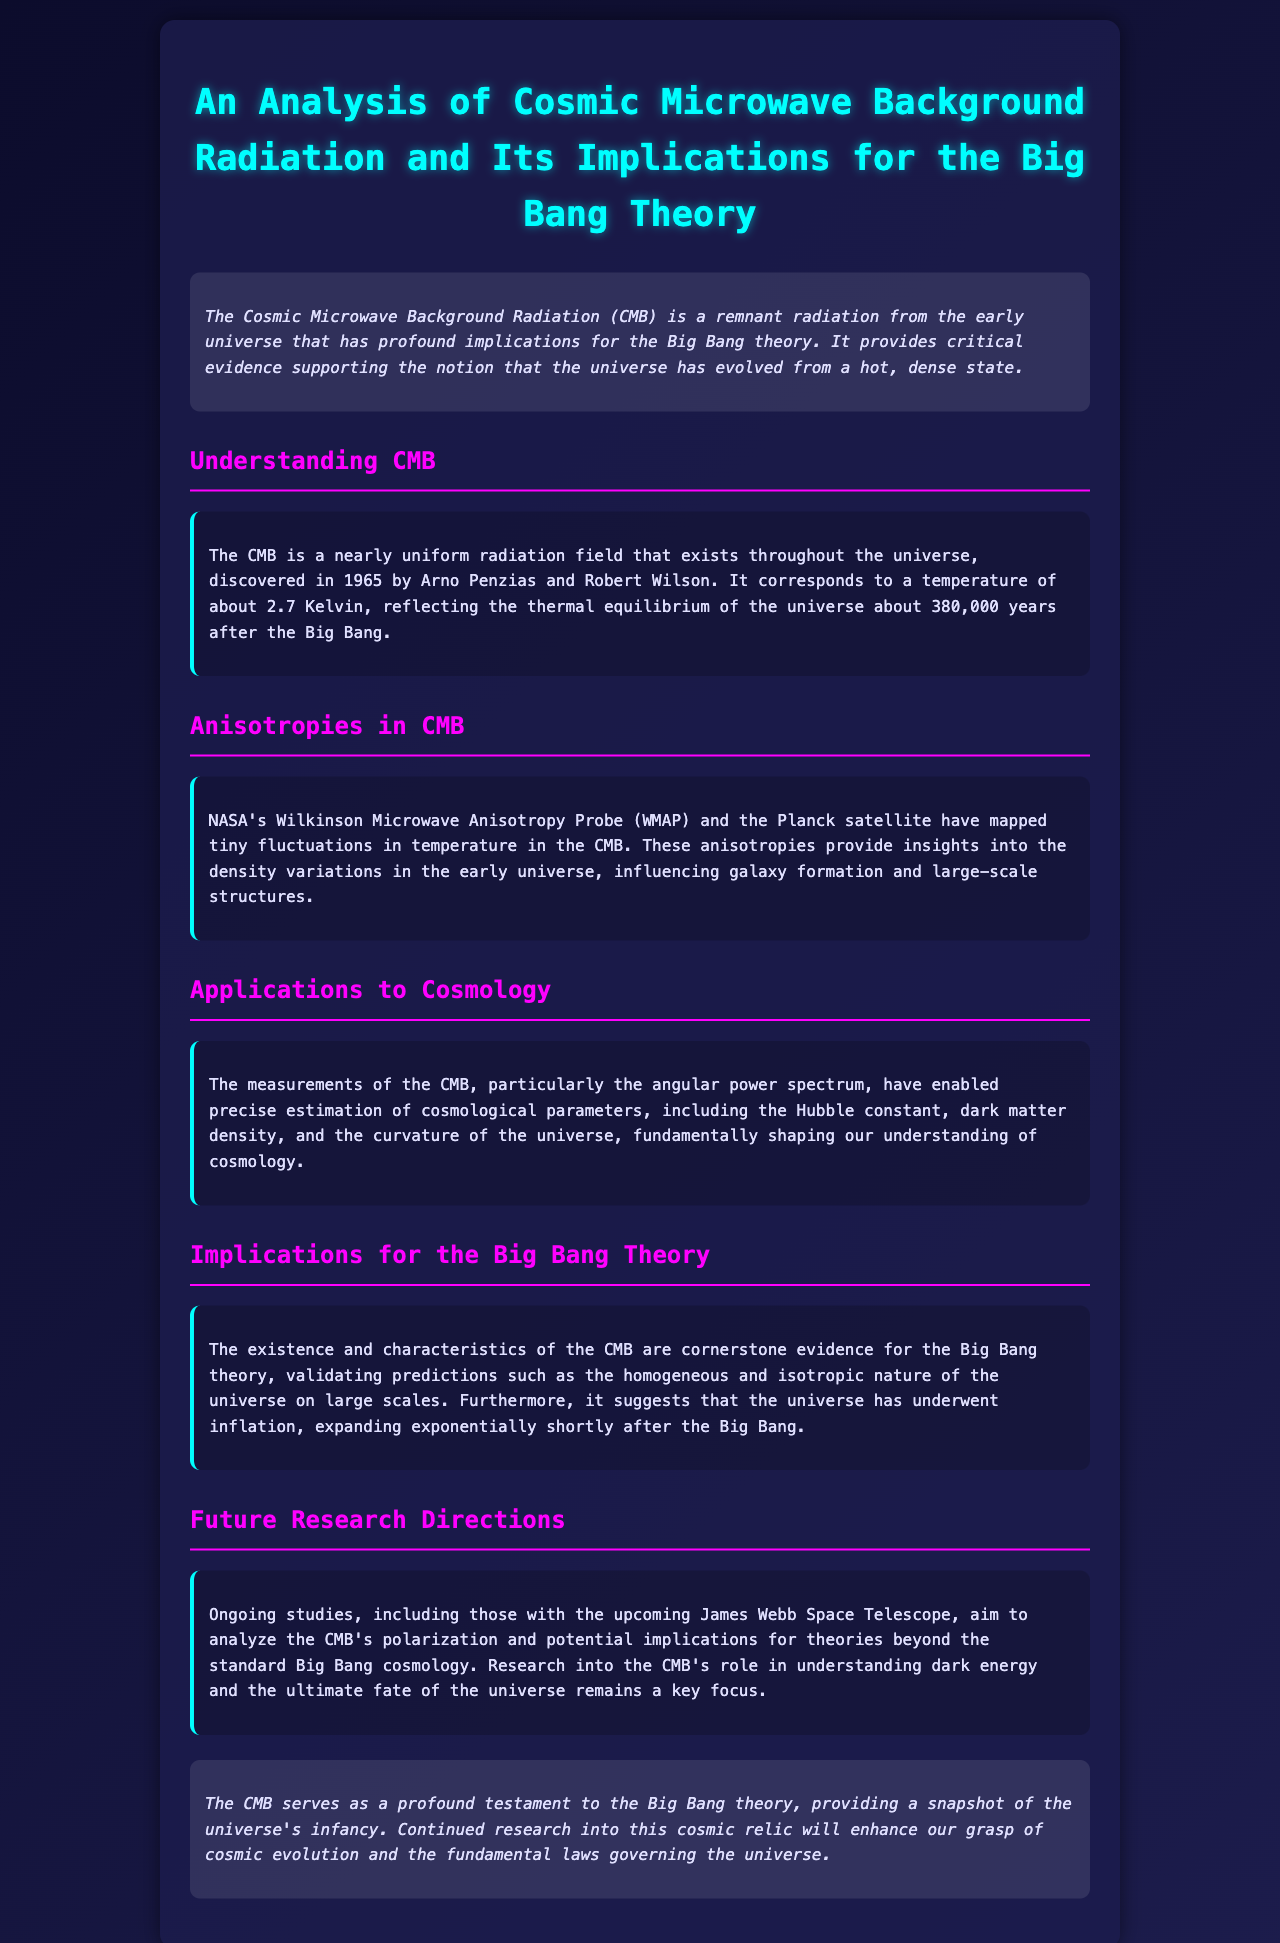What is the temperature of the CMB? The CMB corresponds to a temperature of about 2.7 Kelvin.
Answer: 2.7 Kelvin Who discovered the CMB? The CMB was discovered in 1965 by Arno Penzias and Robert Wilson.
Answer: Arno Penzias and Robert Wilson What do anisotropies in the CMB reveal? Anisotropies in the CMB provide insights into the density variations in the early universe.
Answer: Density variations Which satellite mapped the CMB anisotropies? NASA's Wilkinson Microwave Anisotropy Probe (WMAP) and the Planck satellite mapped the CMB anisotropies.
Answer: WMAP and Planck What are some cosmological parameters determined from CMB measurements? Measurements of the CMB have enabled estimation of the Hubble constant, dark matter density, and the curvature of the universe.
Answer: Hubble constant, dark matter density, curvature What does the existence of the CMB validate? The existence of the CMB validates predictions such as the homogeneous and isotropic nature of the universe on large scales.
Answer: Homogeneous and isotropic nature Which telescope will aid in future studies of the CMB? The upcoming James Webb Space Telescope will aid in future studies of the CMB.
Answer: James Webb Space Telescope What does future research on the CMB aim to understand? Future research aims to understand dark energy and the ultimate fate of the universe.
Answer: Dark energy and ultimate fate of the universe What is the conclusion about the CMB's significance? The CMB serves as a profound testament to the Big Bang theory and cosmic evolution.
Answer: Testament to the Big Bang theory 